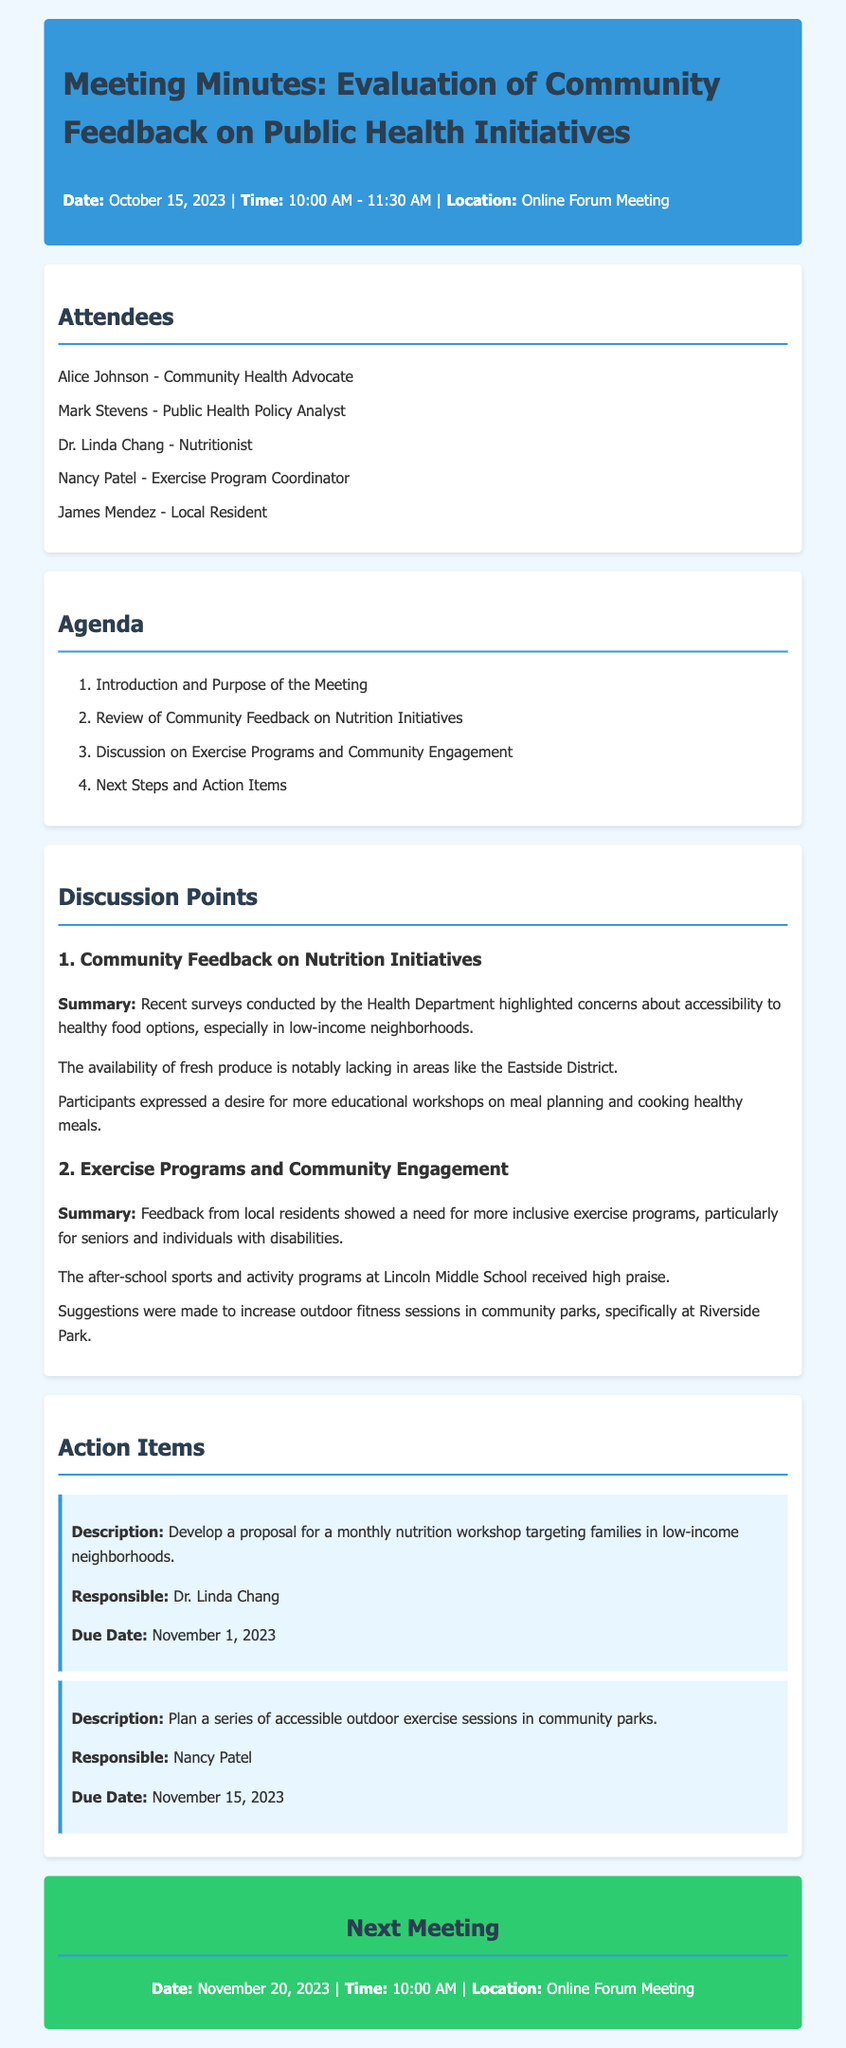What was the date of the meeting? The date of the meeting is mentioned in the header section of the document.
Answer: October 15, 2023 Who is responsible for the nutrition workshop proposal? The action items section specifies who is responsible for each task.
Answer: Dr. Linda Chang What is the due date for planning the outdoor exercise sessions? The due date for this action item is provided in the action items section.
Answer: November 15, 2023 Which area is specifically mentioned as lacking fresh produce? The summary of community feedback on nutrition initiatives highlights this concern.
Answer: Eastside District What type of programs received high praise from local residents? This information is found in the discussion points regarding exercise programs.
Answer: After-school sports and activity programs What is one suggestion made for improving exercise programs? The document outlines community feedback that includes various suggestions.
Answer: Increase outdoor fitness sessions How long is the next meeting scheduled to last? The original meeting duration is stated in the document details.
Answer: 1 hour and 30 minutes What workshop topic was highlighted as a need in low-income neighborhoods? This is indicated in the feedback summary on nutrition initiatives.
Answer: Meal planning and cooking healthy meals What is the location of the next meeting? The upcoming meeting details provide this information clearly.
Answer: Online Forum Meeting 